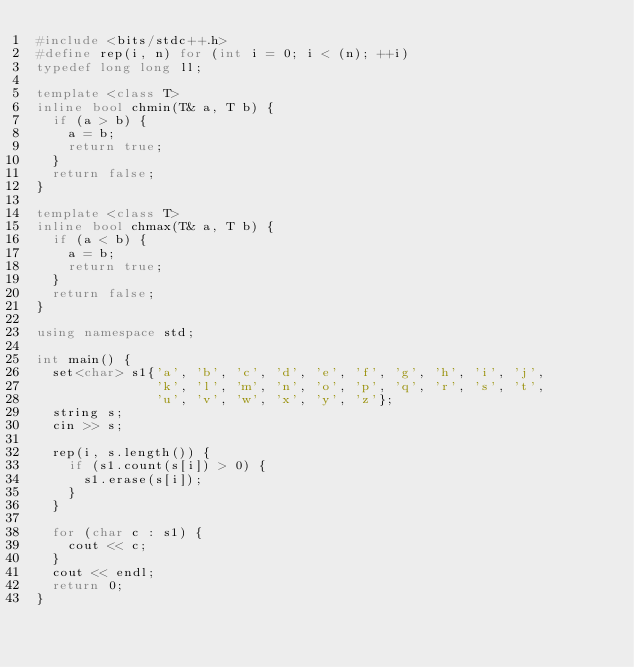Convert code to text. <code><loc_0><loc_0><loc_500><loc_500><_C++_>#include <bits/stdc++.h>
#define rep(i, n) for (int i = 0; i < (n); ++i)
typedef long long ll;

template <class T>
inline bool chmin(T& a, T b) {
  if (a > b) {
    a = b;
    return true;
  }
  return false;
}

template <class T>
inline bool chmax(T& a, T b) {
  if (a < b) {
    a = b;
    return true;
  }
  return false;
}

using namespace std;

int main() {
  set<char> s1{'a', 'b', 'c', 'd', 'e', 'f', 'g', 'h', 'i', 'j',
               'k', 'l', 'm', 'n', 'o', 'p', 'q', 'r', 's', 't',
               'u', 'v', 'w', 'x', 'y', 'z'};
  string s;
  cin >> s;

  rep(i, s.length()) {
    if (s1.count(s[i]) > 0) {
      s1.erase(s[i]);
    }
  }

  for (char c : s1) {
    cout << c;
  }
  cout << endl;
  return 0;
}</code> 